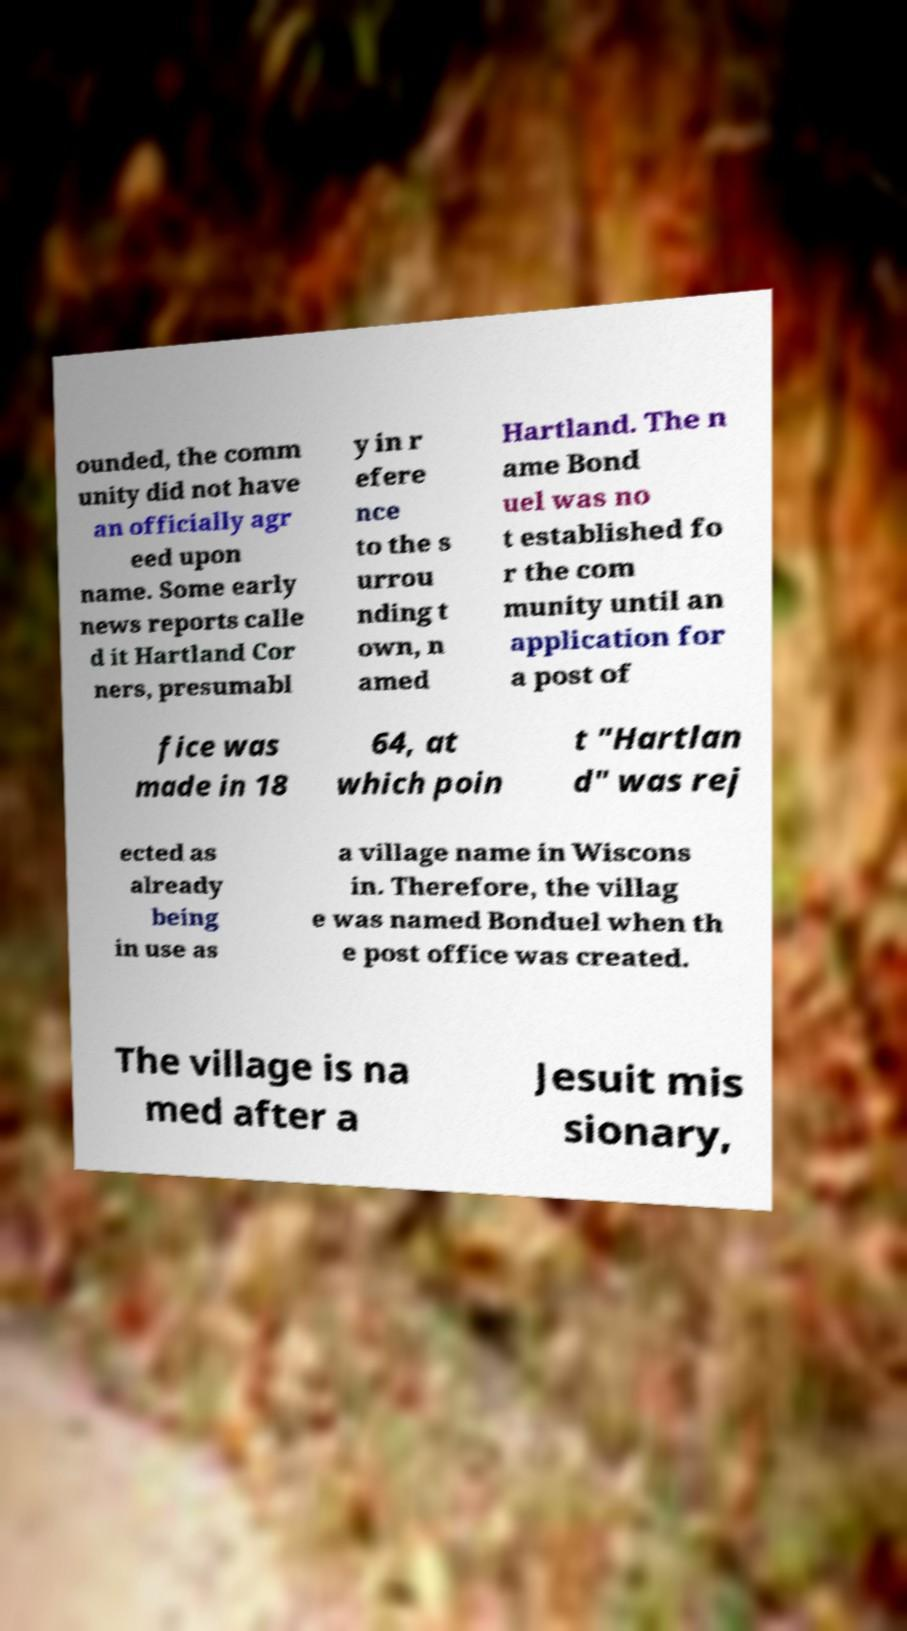For documentation purposes, I need the text within this image transcribed. Could you provide that? ounded, the comm unity did not have an officially agr eed upon name. Some early news reports calle d it Hartland Cor ners, presumabl y in r efere nce to the s urrou nding t own, n amed Hartland. The n ame Bond uel was no t established fo r the com munity until an application for a post of fice was made in 18 64, at which poin t "Hartlan d" was rej ected as already being in use as a village name in Wiscons in. Therefore, the villag e was named Bonduel when th e post office was created. The village is na med after a Jesuit mis sionary, 